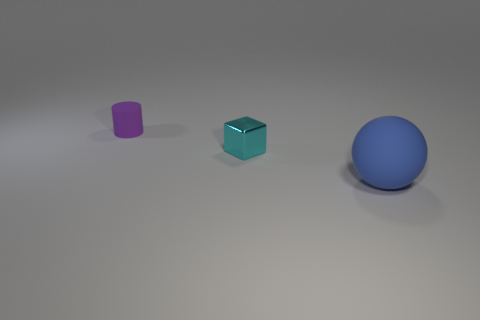Add 1 big purple metal cylinders. How many objects exist? 4 Subtract all balls. How many objects are left? 2 Add 1 small objects. How many small objects exist? 3 Subtract 0 red cylinders. How many objects are left? 3 Subtract all brown blocks. Subtract all small metallic blocks. How many objects are left? 2 Add 1 large blue things. How many large blue things are left? 2 